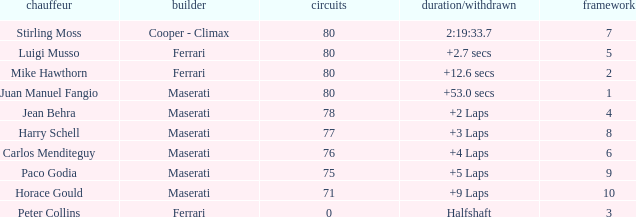Who was driving the Maserati with a Grid smaller than 6, and a Time/Retired of +2 laps? Jean Behra. 